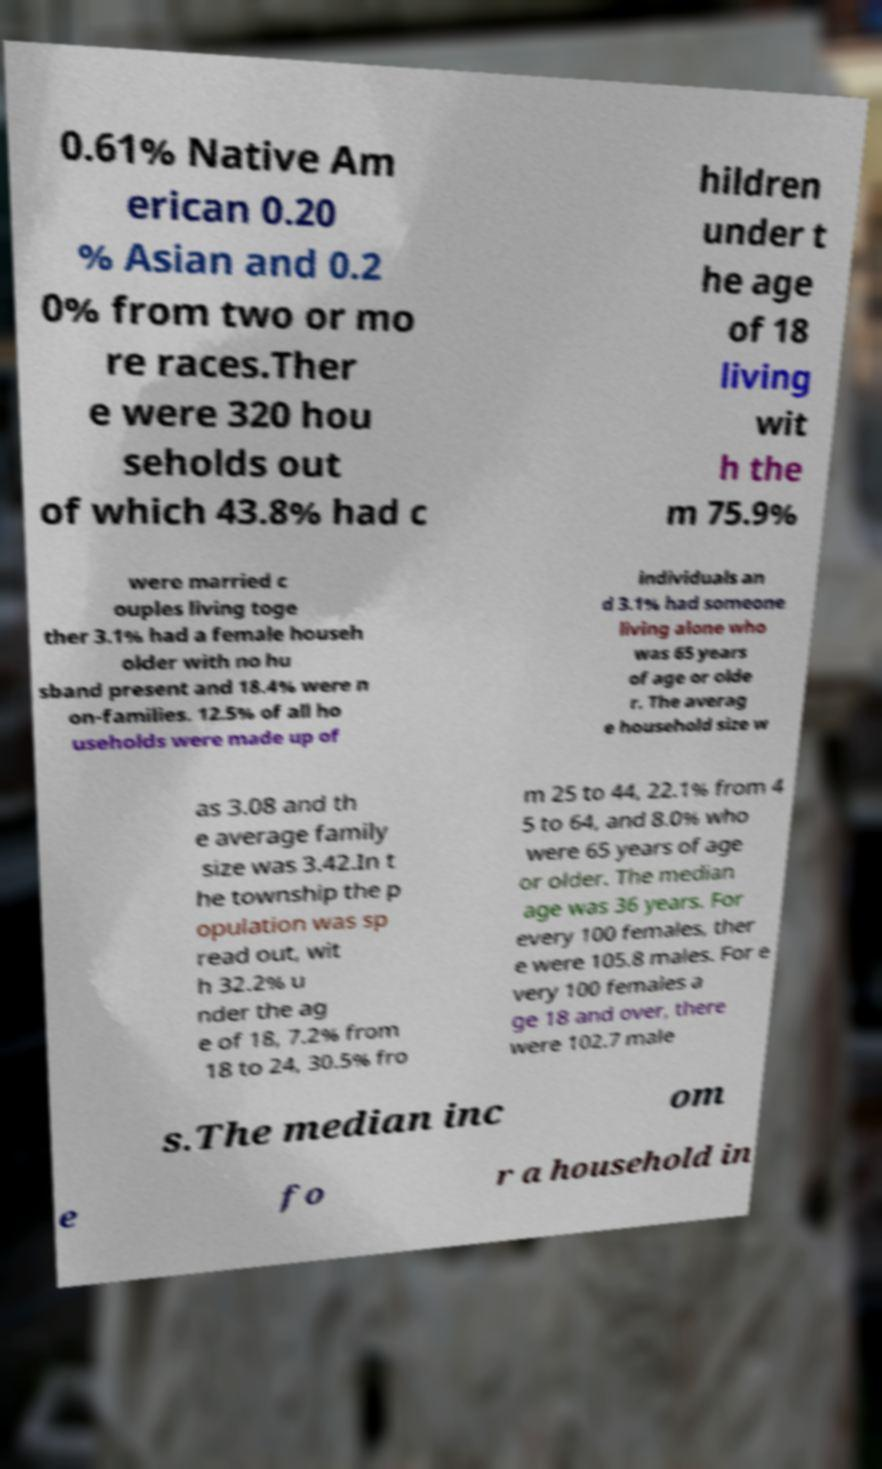Can you accurately transcribe the text from the provided image for me? 0.61% Native Am erican 0.20 % Asian and 0.2 0% from two or mo re races.Ther e were 320 hou seholds out of which 43.8% had c hildren under t he age of 18 living wit h the m 75.9% were married c ouples living toge ther 3.1% had a female househ older with no hu sband present and 18.4% were n on-families. 12.5% of all ho useholds were made up of individuals an d 3.1% had someone living alone who was 65 years of age or olde r. The averag e household size w as 3.08 and th e average family size was 3.42.In t he township the p opulation was sp read out, wit h 32.2% u nder the ag e of 18, 7.2% from 18 to 24, 30.5% fro m 25 to 44, 22.1% from 4 5 to 64, and 8.0% who were 65 years of age or older. The median age was 36 years. For every 100 females, ther e were 105.8 males. For e very 100 females a ge 18 and over, there were 102.7 male s.The median inc om e fo r a household in 